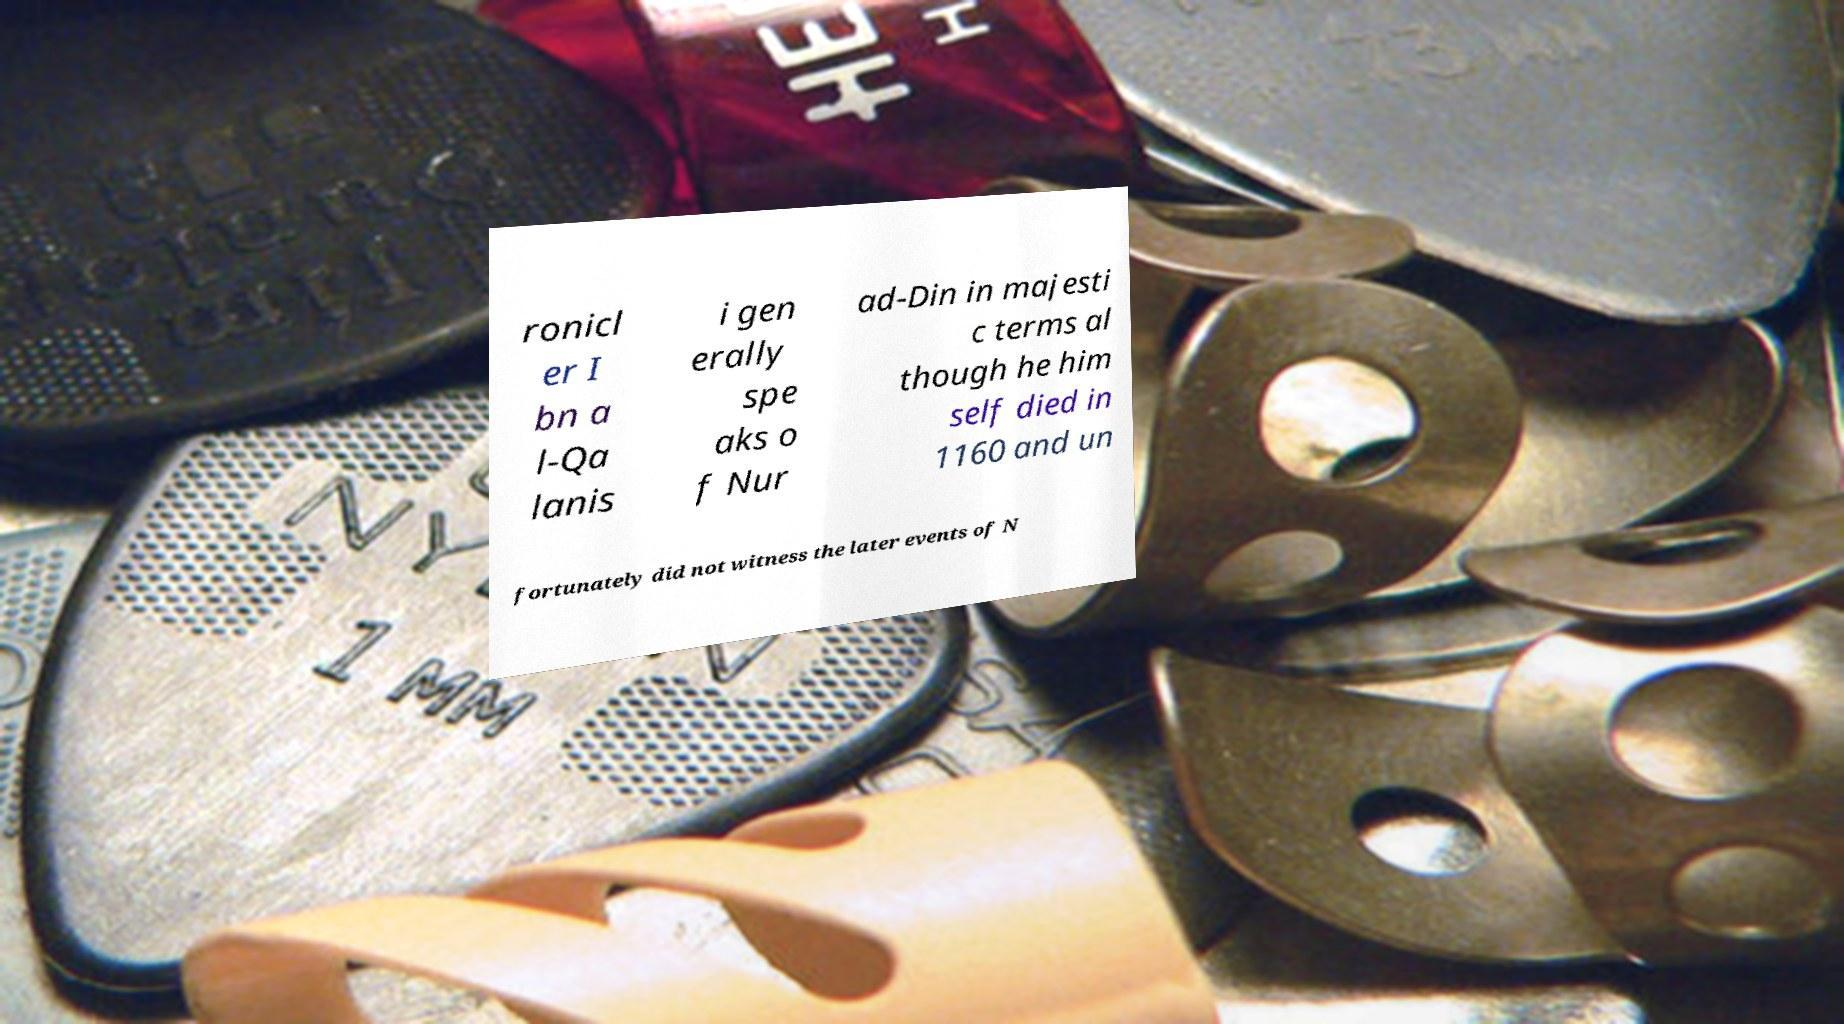Please read and relay the text visible in this image. What does it say? ronicl er I bn a l-Qa lanis i gen erally spe aks o f Nur ad-Din in majesti c terms al though he him self died in 1160 and un fortunately did not witness the later events of N 